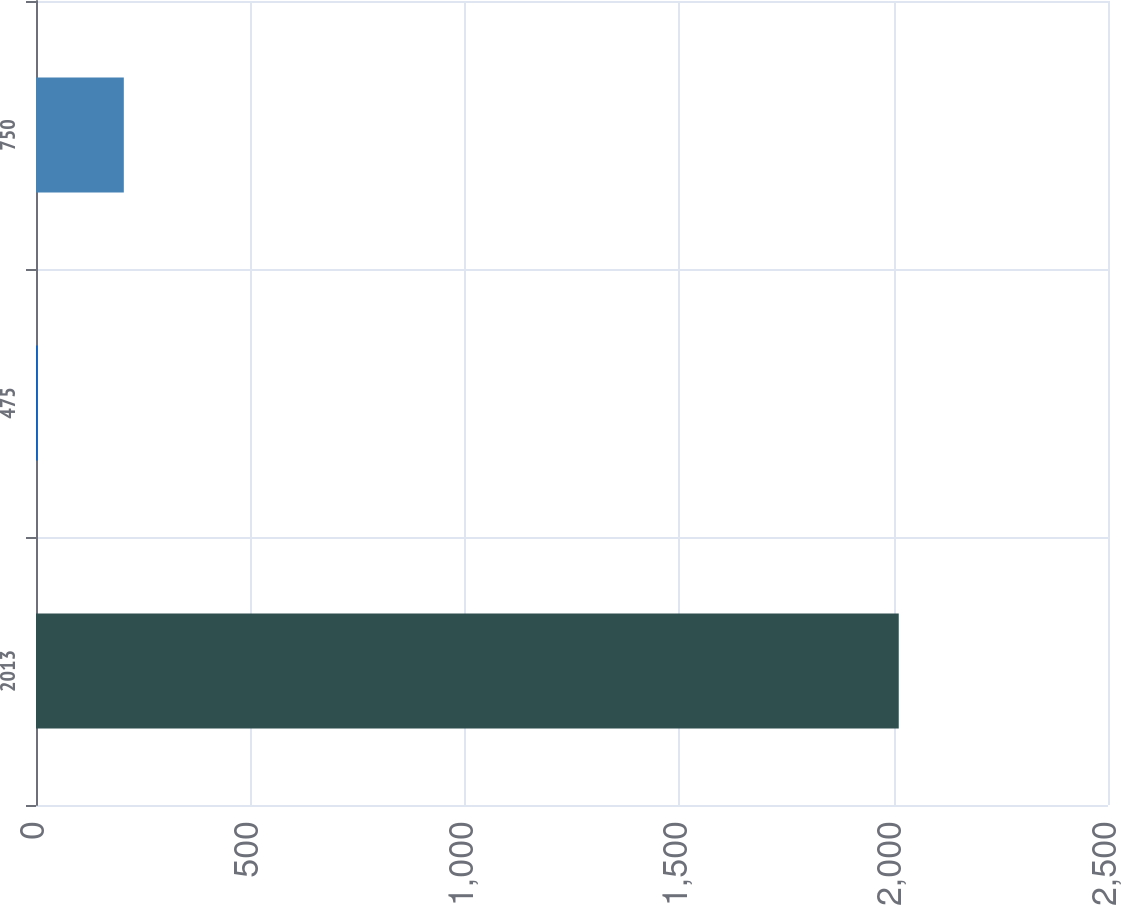Convert chart. <chart><loc_0><loc_0><loc_500><loc_500><bar_chart><fcel>2013<fcel>475<fcel>750<nl><fcel>2012<fcel>4<fcel>204.8<nl></chart> 